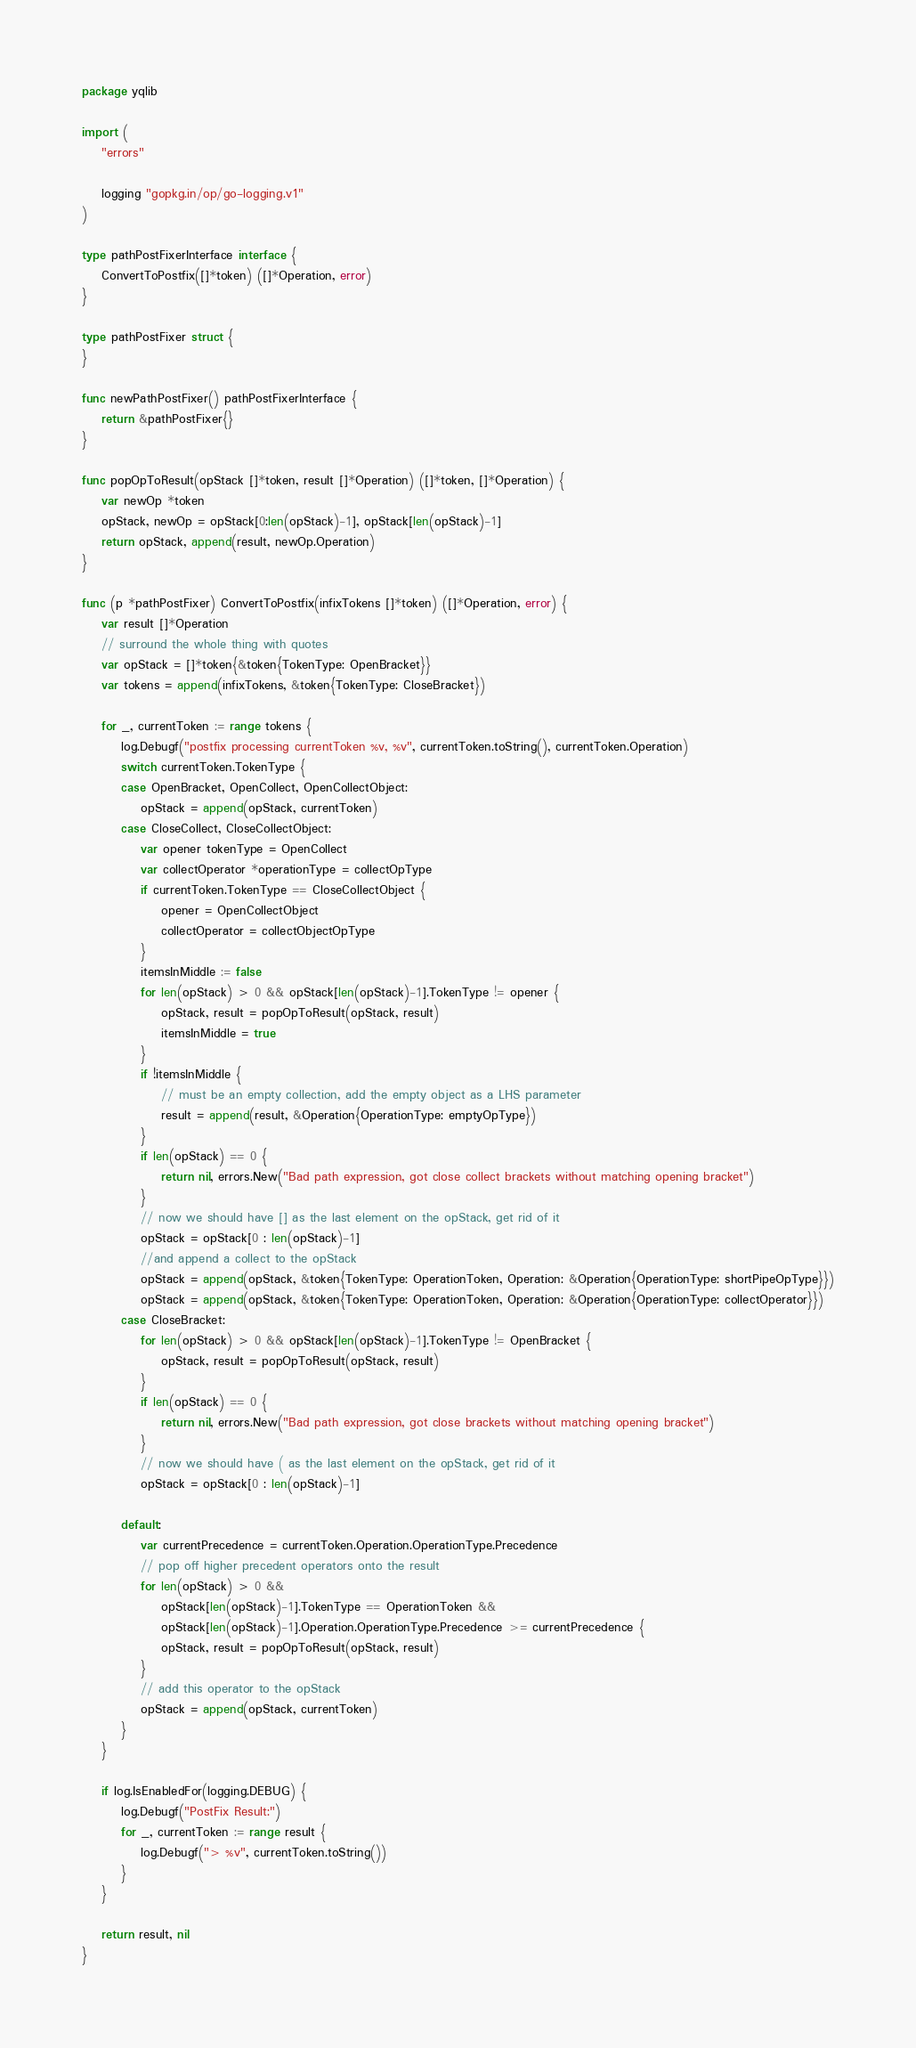<code> <loc_0><loc_0><loc_500><loc_500><_Go_>package yqlib

import (
	"errors"

	logging "gopkg.in/op/go-logging.v1"
)

type pathPostFixerInterface interface {
	ConvertToPostfix([]*token) ([]*Operation, error)
}

type pathPostFixer struct {
}

func newPathPostFixer() pathPostFixerInterface {
	return &pathPostFixer{}
}

func popOpToResult(opStack []*token, result []*Operation) ([]*token, []*Operation) {
	var newOp *token
	opStack, newOp = opStack[0:len(opStack)-1], opStack[len(opStack)-1]
	return opStack, append(result, newOp.Operation)
}

func (p *pathPostFixer) ConvertToPostfix(infixTokens []*token) ([]*Operation, error) {
	var result []*Operation
	// surround the whole thing with quotes
	var opStack = []*token{&token{TokenType: OpenBracket}}
	var tokens = append(infixTokens, &token{TokenType: CloseBracket})

	for _, currentToken := range tokens {
		log.Debugf("postfix processing currentToken %v, %v", currentToken.toString(), currentToken.Operation)
		switch currentToken.TokenType {
		case OpenBracket, OpenCollect, OpenCollectObject:
			opStack = append(opStack, currentToken)
		case CloseCollect, CloseCollectObject:
			var opener tokenType = OpenCollect
			var collectOperator *operationType = collectOpType
			if currentToken.TokenType == CloseCollectObject {
				opener = OpenCollectObject
				collectOperator = collectObjectOpType
			}
			itemsInMiddle := false
			for len(opStack) > 0 && opStack[len(opStack)-1].TokenType != opener {
				opStack, result = popOpToResult(opStack, result)
				itemsInMiddle = true
			}
			if !itemsInMiddle {
				// must be an empty collection, add the empty object as a LHS parameter
				result = append(result, &Operation{OperationType: emptyOpType})
			}
			if len(opStack) == 0 {
				return nil, errors.New("Bad path expression, got close collect brackets without matching opening bracket")
			}
			// now we should have [] as the last element on the opStack, get rid of it
			opStack = opStack[0 : len(opStack)-1]
			//and append a collect to the opStack
			opStack = append(opStack, &token{TokenType: OperationToken, Operation: &Operation{OperationType: shortPipeOpType}})
			opStack = append(opStack, &token{TokenType: OperationToken, Operation: &Operation{OperationType: collectOperator}})
		case CloseBracket:
			for len(opStack) > 0 && opStack[len(opStack)-1].TokenType != OpenBracket {
				opStack, result = popOpToResult(opStack, result)
			}
			if len(opStack) == 0 {
				return nil, errors.New("Bad path expression, got close brackets without matching opening bracket")
			}
			// now we should have ( as the last element on the opStack, get rid of it
			opStack = opStack[0 : len(opStack)-1]

		default:
			var currentPrecedence = currentToken.Operation.OperationType.Precedence
			// pop off higher precedent operators onto the result
			for len(opStack) > 0 &&
				opStack[len(opStack)-1].TokenType == OperationToken &&
				opStack[len(opStack)-1].Operation.OperationType.Precedence >= currentPrecedence {
				opStack, result = popOpToResult(opStack, result)
			}
			// add this operator to the opStack
			opStack = append(opStack, currentToken)
		}
	}

	if log.IsEnabledFor(logging.DEBUG) {
		log.Debugf("PostFix Result:")
		for _, currentToken := range result {
			log.Debugf("> %v", currentToken.toString())
		}
	}

	return result, nil
}
</code> 